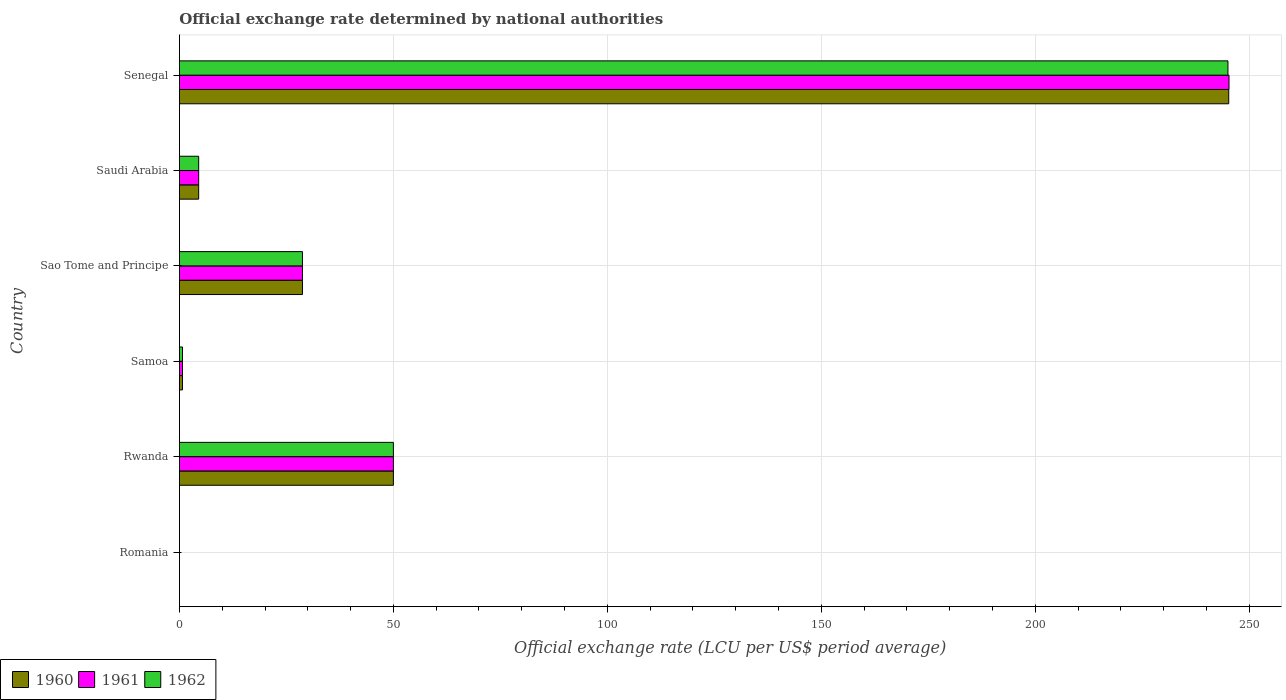How many different coloured bars are there?
Your answer should be compact. 3. Are the number of bars per tick equal to the number of legend labels?
Provide a succinct answer. Yes. Are the number of bars on each tick of the Y-axis equal?
Give a very brief answer. Yes. How many bars are there on the 2nd tick from the top?
Keep it short and to the point. 3. What is the label of the 4th group of bars from the top?
Your answer should be very brief. Samoa. What is the official exchange rate in 1961 in Senegal?
Ensure brevity in your answer.  245.26. Across all countries, what is the maximum official exchange rate in 1962?
Make the answer very short. 245.01. Across all countries, what is the minimum official exchange rate in 1960?
Keep it short and to the point. 0. In which country was the official exchange rate in 1960 maximum?
Provide a short and direct response. Senegal. In which country was the official exchange rate in 1961 minimum?
Ensure brevity in your answer.  Romania. What is the total official exchange rate in 1962 in the graph?
Make the answer very short. 328.98. What is the difference between the official exchange rate in 1962 in Saudi Arabia and that in Senegal?
Give a very brief answer. -240.51. What is the difference between the official exchange rate in 1961 in Rwanda and the official exchange rate in 1960 in Sao Tome and Principe?
Offer a very short reply. 21.25. What is the average official exchange rate in 1960 per country?
Offer a very short reply. 54.86. In how many countries, is the official exchange rate in 1961 greater than 60 LCU?
Give a very brief answer. 1. What is the ratio of the official exchange rate in 1961 in Romania to that in Rwanda?
Make the answer very short. 1.2000000009999998e-5. Is the difference between the official exchange rate in 1960 in Romania and Senegal greater than the difference between the official exchange rate in 1962 in Romania and Senegal?
Keep it short and to the point. No. What is the difference between the highest and the second highest official exchange rate in 1962?
Give a very brief answer. 195.01. What is the difference between the highest and the lowest official exchange rate in 1962?
Ensure brevity in your answer.  245.01. What does the 3rd bar from the bottom in Rwanda represents?
Your answer should be compact. 1962. Is it the case that in every country, the sum of the official exchange rate in 1962 and official exchange rate in 1961 is greater than the official exchange rate in 1960?
Offer a very short reply. Yes. How many bars are there?
Your response must be concise. 18. Are the values on the major ticks of X-axis written in scientific E-notation?
Give a very brief answer. No. How are the legend labels stacked?
Your answer should be compact. Horizontal. What is the title of the graph?
Your answer should be compact. Official exchange rate determined by national authorities. Does "1978" appear as one of the legend labels in the graph?
Your answer should be very brief. No. What is the label or title of the X-axis?
Keep it short and to the point. Official exchange rate (LCU per US$ period average). What is the label or title of the Y-axis?
Provide a succinct answer. Country. What is the Official exchange rate (LCU per US$ period average) in 1960 in Romania?
Give a very brief answer. 0. What is the Official exchange rate (LCU per US$ period average) of 1961 in Romania?
Your answer should be very brief. 0. What is the Official exchange rate (LCU per US$ period average) in 1962 in Romania?
Provide a short and direct response. 0. What is the Official exchange rate (LCU per US$ period average) of 1960 in Rwanda?
Keep it short and to the point. 50. What is the Official exchange rate (LCU per US$ period average) in 1961 in Rwanda?
Keep it short and to the point. 50. What is the Official exchange rate (LCU per US$ period average) of 1962 in Rwanda?
Offer a very short reply. 50. What is the Official exchange rate (LCU per US$ period average) in 1960 in Samoa?
Provide a succinct answer. 0.71. What is the Official exchange rate (LCU per US$ period average) of 1961 in Samoa?
Make the answer very short. 0.72. What is the Official exchange rate (LCU per US$ period average) in 1962 in Samoa?
Offer a very short reply. 0.72. What is the Official exchange rate (LCU per US$ period average) in 1960 in Sao Tome and Principe?
Your answer should be very brief. 28.75. What is the Official exchange rate (LCU per US$ period average) in 1961 in Sao Tome and Principe?
Offer a terse response. 28.75. What is the Official exchange rate (LCU per US$ period average) of 1962 in Sao Tome and Principe?
Provide a short and direct response. 28.75. What is the Official exchange rate (LCU per US$ period average) in 1960 in Saudi Arabia?
Keep it short and to the point. 4.5. What is the Official exchange rate (LCU per US$ period average) of 1961 in Saudi Arabia?
Ensure brevity in your answer.  4.5. What is the Official exchange rate (LCU per US$ period average) in 1962 in Saudi Arabia?
Your answer should be compact. 4.5. What is the Official exchange rate (LCU per US$ period average) of 1960 in Senegal?
Provide a short and direct response. 245.2. What is the Official exchange rate (LCU per US$ period average) in 1961 in Senegal?
Provide a succinct answer. 245.26. What is the Official exchange rate (LCU per US$ period average) of 1962 in Senegal?
Ensure brevity in your answer.  245.01. Across all countries, what is the maximum Official exchange rate (LCU per US$ period average) in 1960?
Provide a short and direct response. 245.2. Across all countries, what is the maximum Official exchange rate (LCU per US$ period average) of 1961?
Give a very brief answer. 245.26. Across all countries, what is the maximum Official exchange rate (LCU per US$ period average) of 1962?
Give a very brief answer. 245.01. Across all countries, what is the minimum Official exchange rate (LCU per US$ period average) of 1960?
Make the answer very short. 0. Across all countries, what is the minimum Official exchange rate (LCU per US$ period average) of 1961?
Keep it short and to the point. 0. Across all countries, what is the minimum Official exchange rate (LCU per US$ period average) in 1962?
Your answer should be compact. 0. What is the total Official exchange rate (LCU per US$ period average) of 1960 in the graph?
Your answer should be compact. 329.16. What is the total Official exchange rate (LCU per US$ period average) of 1961 in the graph?
Provide a short and direct response. 329.23. What is the total Official exchange rate (LCU per US$ period average) of 1962 in the graph?
Keep it short and to the point. 328.98. What is the difference between the Official exchange rate (LCU per US$ period average) of 1960 in Romania and that in Rwanda?
Provide a short and direct response. -50. What is the difference between the Official exchange rate (LCU per US$ period average) in 1961 in Romania and that in Rwanda?
Offer a terse response. -50. What is the difference between the Official exchange rate (LCU per US$ period average) in 1962 in Romania and that in Rwanda?
Your response must be concise. -50. What is the difference between the Official exchange rate (LCU per US$ period average) in 1960 in Romania and that in Samoa?
Keep it short and to the point. -0.71. What is the difference between the Official exchange rate (LCU per US$ period average) in 1961 in Romania and that in Samoa?
Your answer should be compact. -0.71. What is the difference between the Official exchange rate (LCU per US$ period average) in 1962 in Romania and that in Samoa?
Keep it short and to the point. -0.72. What is the difference between the Official exchange rate (LCU per US$ period average) of 1960 in Romania and that in Sao Tome and Principe?
Make the answer very short. -28.75. What is the difference between the Official exchange rate (LCU per US$ period average) of 1961 in Romania and that in Sao Tome and Principe?
Keep it short and to the point. -28.75. What is the difference between the Official exchange rate (LCU per US$ period average) of 1962 in Romania and that in Sao Tome and Principe?
Provide a succinct answer. -28.75. What is the difference between the Official exchange rate (LCU per US$ period average) in 1960 in Romania and that in Saudi Arabia?
Provide a succinct answer. -4.5. What is the difference between the Official exchange rate (LCU per US$ period average) in 1961 in Romania and that in Saudi Arabia?
Keep it short and to the point. -4.5. What is the difference between the Official exchange rate (LCU per US$ period average) in 1962 in Romania and that in Saudi Arabia?
Ensure brevity in your answer.  -4.5. What is the difference between the Official exchange rate (LCU per US$ period average) in 1960 in Romania and that in Senegal?
Make the answer very short. -245.19. What is the difference between the Official exchange rate (LCU per US$ period average) of 1961 in Romania and that in Senegal?
Make the answer very short. -245.26. What is the difference between the Official exchange rate (LCU per US$ period average) of 1962 in Romania and that in Senegal?
Provide a short and direct response. -245.01. What is the difference between the Official exchange rate (LCU per US$ period average) in 1960 in Rwanda and that in Samoa?
Ensure brevity in your answer.  49.29. What is the difference between the Official exchange rate (LCU per US$ period average) in 1961 in Rwanda and that in Samoa?
Provide a short and direct response. 49.28. What is the difference between the Official exchange rate (LCU per US$ period average) of 1962 in Rwanda and that in Samoa?
Your answer should be compact. 49.28. What is the difference between the Official exchange rate (LCU per US$ period average) in 1960 in Rwanda and that in Sao Tome and Principe?
Your answer should be compact. 21.25. What is the difference between the Official exchange rate (LCU per US$ period average) of 1961 in Rwanda and that in Sao Tome and Principe?
Your answer should be compact. 21.25. What is the difference between the Official exchange rate (LCU per US$ period average) of 1962 in Rwanda and that in Sao Tome and Principe?
Ensure brevity in your answer.  21.25. What is the difference between the Official exchange rate (LCU per US$ period average) in 1960 in Rwanda and that in Saudi Arabia?
Offer a very short reply. 45.5. What is the difference between the Official exchange rate (LCU per US$ period average) of 1961 in Rwanda and that in Saudi Arabia?
Your response must be concise. 45.5. What is the difference between the Official exchange rate (LCU per US$ period average) in 1962 in Rwanda and that in Saudi Arabia?
Provide a succinct answer. 45.5. What is the difference between the Official exchange rate (LCU per US$ period average) in 1960 in Rwanda and that in Senegal?
Your response must be concise. -195.2. What is the difference between the Official exchange rate (LCU per US$ period average) of 1961 in Rwanda and that in Senegal?
Offer a very short reply. -195.26. What is the difference between the Official exchange rate (LCU per US$ period average) in 1962 in Rwanda and that in Senegal?
Provide a succinct answer. -195.01. What is the difference between the Official exchange rate (LCU per US$ period average) of 1960 in Samoa and that in Sao Tome and Principe?
Your answer should be compact. -28.04. What is the difference between the Official exchange rate (LCU per US$ period average) in 1961 in Samoa and that in Sao Tome and Principe?
Keep it short and to the point. -28.03. What is the difference between the Official exchange rate (LCU per US$ period average) in 1962 in Samoa and that in Sao Tome and Principe?
Provide a succinct answer. -28.03. What is the difference between the Official exchange rate (LCU per US$ period average) of 1960 in Samoa and that in Saudi Arabia?
Your response must be concise. -3.79. What is the difference between the Official exchange rate (LCU per US$ period average) in 1961 in Samoa and that in Saudi Arabia?
Give a very brief answer. -3.78. What is the difference between the Official exchange rate (LCU per US$ period average) of 1962 in Samoa and that in Saudi Arabia?
Your response must be concise. -3.78. What is the difference between the Official exchange rate (LCU per US$ period average) in 1960 in Samoa and that in Senegal?
Your answer should be compact. -244.48. What is the difference between the Official exchange rate (LCU per US$ period average) of 1961 in Samoa and that in Senegal?
Keep it short and to the point. -244.54. What is the difference between the Official exchange rate (LCU per US$ period average) in 1962 in Samoa and that in Senegal?
Keep it short and to the point. -244.29. What is the difference between the Official exchange rate (LCU per US$ period average) of 1960 in Sao Tome and Principe and that in Saudi Arabia?
Ensure brevity in your answer.  24.25. What is the difference between the Official exchange rate (LCU per US$ period average) in 1961 in Sao Tome and Principe and that in Saudi Arabia?
Make the answer very short. 24.25. What is the difference between the Official exchange rate (LCU per US$ period average) in 1962 in Sao Tome and Principe and that in Saudi Arabia?
Provide a succinct answer. 24.25. What is the difference between the Official exchange rate (LCU per US$ period average) in 1960 in Sao Tome and Principe and that in Senegal?
Your answer should be very brief. -216.45. What is the difference between the Official exchange rate (LCU per US$ period average) in 1961 in Sao Tome and Principe and that in Senegal?
Ensure brevity in your answer.  -216.51. What is the difference between the Official exchange rate (LCU per US$ period average) in 1962 in Sao Tome and Principe and that in Senegal?
Provide a succinct answer. -216.26. What is the difference between the Official exchange rate (LCU per US$ period average) of 1960 in Saudi Arabia and that in Senegal?
Keep it short and to the point. -240.7. What is the difference between the Official exchange rate (LCU per US$ period average) in 1961 in Saudi Arabia and that in Senegal?
Your response must be concise. -240.76. What is the difference between the Official exchange rate (LCU per US$ period average) of 1962 in Saudi Arabia and that in Senegal?
Your response must be concise. -240.51. What is the difference between the Official exchange rate (LCU per US$ period average) in 1960 in Romania and the Official exchange rate (LCU per US$ period average) in 1961 in Rwanda?
Your response must be concise. -50. What is the difference between the Official exchange rate (LCU per US$ period average) in 1960 in Romania and the Official exchange rate (LCU per US$ period average) in 1962 in Rwanda?
Offer a terse response. -50. What is the difference between the Official exchange rate (LCU per US$ period average) of 1961 in Romania and the Official exchange rate (LCU per US$ period average) of 1962 in Rwanda?
Make the answer very short. -50. What is the difference between the Official exchange rate (LCU per US$ period average) of 1960 in Romania and the Official exchange rate (LCU per US$ period average) of 1961 in Samoa?
Offer a terse response. -0.71. What is the difference between the Official exchange rate (LCU per US$ period average) in 1960 in Romania and the Official exchange rate (LCU per US$ period average) in 1962 in Samoa?
Provide a short and direct response. -0.72. What is the difference between the Official exchange rate (LCU per US$ period average) in 1961 in Romania and the Official exchange rate (LCU per US$ period average) in 1962 in Samoa?
Keep it short and to the point. -0.72. What is the difference between the Official exchange rate (LCU per US$ period average) in 1960 in Romania and the Official exchange rate (LCU per US$ period average) in 1961 in Sao Tome and Principe?
Your response must be concise. -28.75. What is the difference between the Official exchange rate (LCU per US$ period average) in 1960 in Romania and the Official exchange rate (LCU per US$ period average) in 1962 in Sao Tome and Principe?
Give a very brief answer. -28.75. What is the difference between the Official exchange rate (LCU per US$ period average) in 1961 in Romania and the Official exchange rate (LCU per US$ period average) in 1962 in Sao Tome and Principe?
Ensure brevity in your answer.  -28.75. What is the difference between the Official exchange rate (LCU per US$ period average) of 1960 in Romania and the Official exchange rate (LCU per US$ period average) of 1961 in Saudi Arabia?
Provide a succinct answer. -4.5. What is the difference between the Official exchange rate (LCU per US$ period average) in 1960 in Romania and the Official exchange rate (LCU per US$ period average) in 1962 in Saudi Arabia?
Make the answer very short. -4.5. What is the difference between the Official exchange rate (LCU per US$ period average) of 1961 in Romania and the Official exchange rate (LCU per US$ period average) of 1962 in Saudi Arabia?
Provide a short and direct response. -4.5. What is the difference between the Official exchange rate (LCU per US$ period average) of 1960 in Romania and the Official exchange rate (LCU per US$ period average) of 1961 in Senegal?
Provide a short and direct response. -245.26. What is the difference between the Official exchange rate (LCU per US$ period average) in 1960 in Romania and the Official exchange rate (LCU per US$ period average) in 1962 in Senegal?
Offer a terse response. -245.01. What is the difference between the Official exchange rate (LCU per US$ period average) in 1961 in Romania and the Official exchange rate (LCU per US$ period average) in 1962 in Senegal?
Offer a very short reply. -245.01. What is the difference between the Official exchange rate (LCU per US$ period average) of 1960 in Rwanda and the Official exchange rate (LCU per US$ period average) of 1961 in Samoa?
Offer a very short reply. 49.28. What is the difference between the Official exchange rate (LCU per US$ period average) of 1960 in Rwanda and the Official exchange rate (LCU per US$ period average) of 1962 in Samoa?
Give a very brief answer. 49.28. What is the difference between the Official exchange rate (LCU per US$ period average) in 1961 in Rwanda and the Official exchange rate (LCU per US$ period average) in 1962 in Samoa?
Offer a terse response. 49.28. What is the difference between the Official exchange rate (LCU per US$ period average) in 1960 in Rwanda and the Official exchange rate (LCU per US$ period average) in 1961 in Sao Tome and Principe?
Provide a succinct answer. 21.25. What is the difference between the Official exchange rate (LCU per US$ period average) of 1960 in Rwanda and the Official exchange rate (LCU per US$ period average) of 1962 in Sao Tome and Principe?
Give a very brief answer. 21.25. What is the difference between the Official exchange rate (LCU per US$ period average) in 1961 in Rwanda and the Official exchange rate (LCU per US$ period average) in 1962 in Sao Tome and Principe?
Offer a very short reply. 21.25. What is the difference between the Official exchange rate (LCU per US$ period average) of 1960 in Rwanda and the Official exchange rate (LCU per US$ period average) of 1961 in Saudi Arabia?
Give a very brief answer. 45.5. What is the difference between the Official exchange rate (LCU per US$ period average) of 1960 in Rwanda and the Official exchange rate (LCU per US$ period average) of 1962 in Saudi Arabia?
Make the answer very short. 45.5. What is the difference between the Official exchange rate (LCU per US$ period average) of 1961 in Rwanda and the Official exchange rate (LCU per US$ period average) of 1962 in Saudi Arabia?
Offer a very short reply. 45.5. What is the difference between the Official exchange rate (LCU per US$ period average) in 1960 in Rwanda and the Official exchange rate (LCU per US$ period average) in 1961 in Senegal?
Keep it short and to the point. -195.26. What is the difference between the Official exchange rate (LCU per US$ period average) of 1960 in Rwanda and the Official exchange rate (LCU per US$ period average) of 1962 in Senegal?
Offer a terse response. -195.01. What is the difference between the Official exchange rate (LCU per US$ period average) of 1961 in Rwanda and the Official exchange rate (LCU per US$ period average) of 1962 in Senegal?
Keep it short and to the point. -195.01. What is the difference between the Official exchange rate (LCU per US$ period average) of 1960 in Samoa and the Official exchange rate (LCU per US$ period average) of 1961 in Sao Tome and Principe?
Provide a short and direct response. -28.04. What is the difference between the Official exchange rate (LCU per US$ period average) in 1960 in Samoa and the Official exchange rate (LCU per US$ period average) in 1962 in Sao Tome and Principe?
Provide a short and direct response. -28.04. What is the difference between the Official exchange rate (LCU per US$ period average) of 1961 in Samoa and the Official exchange rate (LCU per US$ period average) of 1962 in Sao Tome and Principe?
Your answer should be very brief. -28.03. What is the difference between the Official exchange rate (LCU per US$ period average) in 1960 in Samoa and the Official exchange rate (LCU per US$ period average) in 1961 in Saudi Arabia?
Your answer should be compact. -3.79. What is the difference between the Official exchange rate (LCU per US$ period average) of 1960 in Samoa and the Official exchange rate (LCU per US$ period average) of 1962 in Saudi Arabia?
Provide a succinct answer. -3.79. What is the difference between the Official exchange rate (LCU per US$ period average) of 1961 in Samoa and the Official exchange rate (LCU per US$ period average) of 1962 in Saudi Arabia?
Your response must be concise. -3.78. What is the difference between the Official exchange rate (LCU per US$ period average) of 1960 in Samoa and the Official exchange rate (LCU per US$ period average) of 1961 in Senegal?
Your answer should be very brief. -244.55. What is the difference between the Official exchange rate (LCU per US$ period average) in 1960 in Samoa and the Official exchange rate (LCU per US$ period average) in 1962 in Senegal?
Provide a succinct answer. -244.3. What is the difference between the Official exchange rate (LCU per US$ period average) in 1961 in Samoa and the Official exchange rate (LCU per US$ period average) in 1962 in Senegal?
Make the answer very short. -244.3. What is the difference between the Official exchange rate (LCU per US$ period average) of 1960 in Sao Tome and Principe and the Official exchange rate (LCU per US$ period average) of 1961 in Saudi Arabia?
Make the answer very short. 24.25. What is the difference between the Official exchange rate (LCU per US$ period average) of 1960 in Sao Tome and Principe and the Official exchange rate (LCU per US$ period average) of 1962 in Saudi Arabia?
Ensure brevity in your answer.  24.25. What is the difference between the Official exchange rate (LCU per US$ period average) in 1961 in Sao Tome and Principe and the Official exchange rate (LCU per US$ period average) in 1962 in Saudi Arabia?
Your response must be concise. 24.25. What is the difference between the Official exchange rate (LCU per US$ period average) of 1960 in Sao Tome and Principe and the Official exchange rate (LCU per US$ period average) of 1961 in Senegal?
Provide a succinct answer. -216.51. What is the difference between the Official exchange rate (LCU per US$ period average) of 1960 in Sao Tome and Principe and the Official exchange rate (LCU per US$ period average) of 1962 in Senegal?
Keep it short and to the point. -216.26. What is the difference between the Official exchange rate (LCU per US$ period average) in 1961 in Sao Tome and Principe and the Official exchange rate (LCU per US$ period average) in 1962 in Senegal?
Offer a very short reply. -216.26. What is the difference between the Official exchange rate (LCU per US$ period average) in 1960 in Saudi Arabia and the Official exchange rate (LCU per US$ period average) in 1961 in Senegal?
Your response must be concise. -240.76. What is the difference between the Official exchange rate (LCU per US$ period average) in 1960 in Saudi Arabia and the Official exchange rate (LCU per US$ period average) in 1962 in Senegal?
Provide a short and direct response. -240.51. What is the difference between the Official exchange rate (LCU per US$ period average) in 1961 in Saudi Arabia and the Official exchange rate (LCU per US$ period average) in 1962 in Senegal?
Provide a short and direct response. -240.51. What is the average Official exchange rate (LCU per US$ period average) in 1960 per country?
Your answer should be very brief. 54.86. What is the average Official exchange rate (LCU per US$ period average) in 1961 per country?
Offer a terse response. 54.87. What is the average Official exchange rate (LCU per US$ period average) in 1962 per country?
Offer a very short reply. 54.83. What is the difference between the Official exchange rate (LCU per US$ period average) of 1960 and Official exchange rate (LCU per US$ period average) of 1961 in Romania?
Offer a terse response. 0. What is the difference between the Official exchange rate (LCU per US$ period average) in 1960 and Official exchange rate (LCU per US$ period average) in 1962 in Romania?
Make the answer very short. 0. What is the difference between the Official exchange rate (LCU per US$ period average) in 1960 and Official exchange rate (LCU per US$ period average) in 1961 in Rwanda?
Give a very brief answer. 0. What is the difference between the Official exchange rate (LCU per US$ period average) in 1960 and Official exchange rate (LCU per US$ period average) in 1962 in Rwanda?
Make the answer very short. 0. What is the difference between the Official exchange rate (LCU per US$ period average) of 1961 and Official exchange rate (LCU per US$ period average) of 1962 in Rwanda?
Offer a very short reply. 0. What is the difference between the Official exchange rate (LCU per US$ period average) of 1960 and Official exchange rate (LCU per US$ period average) of 1961 in Samoa?
Your response must be concise. -0. What is the difference between the Official exchange rate (LCU per US$ period average) in 1960 and Official exchange rate (LCU per US$ period average) in 1962 in Samoa?
Offer a terse response. -0. What is the difference between the Official exchange rate (LCU per US$ period average) in 1961 and Official exchange rate (LCU per US$ period average) in 1962 in Samoa?
Give a very brief answer. -0. What is the difference between the Official exchange rate (LCU per US$ period average) of 1961 and Official exchange rate (LCU per US$ period average) of 1962 in Sao Tome and Principe?
Ensure brevity in your answer.  0. What is the difference between the Official exchange rate (LCU per US$ period average) of 1960 and Official exchange rate (LCU per US$ period average) of 1961 in Saudi Arabia?
Offer a terse response. 0. What is the difference between the Official exchange rate (LCU per US$ period average) in 1961 and Official exchange rate (LCU per US$ period average) in 1962 in Saudi Arabia?
Keep it short and to the point. 0. What is the difference between the Official exchange rate (LCU per US$ period average) of 1960 and Official exchange rate (LCU per US$ period average) of 1961 in Senegal?
Your response must be concise. -0.07. What is the difference between the Official exchange rate (LCU per US$ period average) of 1960 and Official exchange rate (LCU per US$ period average) of 1962 in Senegal?
Make the answer very short. 0.18. What is the difference between the Official exchange rate (LCU per US$ period average) of 1961 and Official exchange rate (LCU per US$ period average) of 1962 in Senegal?
Your response must be concise. 0.25. What is the ratio of the Official exchange rate (LCU per US$ period average) of 1961 in Romania to that in Rwanda?
Your answer should be very brief. 0. What is the ratio of the Official exchange rate (LCU per US$ period average) of 1960 in Romania to that in Samoa?
Ensure brevity in your answer.  0. What is the ratio of the Official exchange rate (LCU per US$ period average) in 1961 in Romania to that in Samoa?
Your answer should be very brief. 0. What is the ratio of the Official exchange rate (LCU per US$ period average) of 1962 in Romania to that in Samoa?
Provide a short and direct response. 0. What is the ratio of the Official exchange rate (LCU per US$ period average) of 1961 in Romania to that in Sao Tome and Principe?
Offer a terse response. 0. What is the ratio of the Official exchange rate (LCU per US$ period average) of 1962 in Romania to that in Sao Tome and Principe?
Provide a succinct answer. 0. What is the ratio of the Official exchange rate (LCU per US$ period average) of 1961 in Romania to that in Saudi Arabia?
Your answer should be very brief. 0. What is the ratio of the Official exchange rate (LCU per US$ period average) of 1962 in Romania to that in Saudi Arabia?
Keep it short and to the point. 0. What is the ratio of the Official exchange rate (LCU per US$ period average) of 1960 in Romania to that in Senegal?
Make the answer very short. 0. What is the ratio of the Official exchange rate (LCU per US$ period average) in 1960 in Rwanda to that in Samoa?
Ensure brevity in your answer.  70. What is the ratio of the Official exchange rate (LCU per US$ period average) of 1961 in Rwanda to that in Samoa?
Ensure brevity in your answer.  69.88. What is the ratio of the Official exchange rate (LCU per US$ period average) of 1962 in Rwanda to that in Samoa?
Your answer should be compact. 69.52. What is the ratio of the Official exchange rate (LCU per US$ period average) in 1960 in Rwanda to that in Sao Tome and Principe?
Ensure brevity in your answer.  1.74. What is the ratio of the Official exchange rate (LCU per US$ period average) in 1961 in Rwanda to that in Sao Tome and Principe?
Your response must be concise. 1.74. What is the ratio of the Official exchange rate (LCU per US$ period average) of 1962 in Rwanda to that in Sao Tome and Principe?
Your response must be concise. 1.74. What is the ratio of the Official exchange rate (LCU per US$ period average) in 1960 in Rwanda to that in Saudi Arabia?
Your response must be concise. 11.11. What is the ratio of the Official exchange rate (LCU per US$ period average) in 1961 in Rwanda to that in Saudi Arabia?
Offer a terse response. 11.11. What is the ratio of the Official exchange rate (LCU per US$ period average) in 1962 in Rwanda to that in Saudi Arabia?
Make the answer very short. 11.11. What is the ratio of the Official exchange rate (LCU per US$ period average) of 1960 in Rwanda to that in Senegal?
Give a very brief answer. 0.2. What is the ratio of the Official exchange rate (LCU per US$ period average) in 1961 in Rwanda to that in Senegal?
Offer a very short reply. 0.2. What is the ratio of the Official exchange rate (LCU per US$ period average) in 1962 in Rwanda to that in Senegal?
Provide a short and direct response. 0.2. What is the ratio of the Official exchange rate (LCU per US$ period average) of 1960 in Samoa to that in Sao Tome and Principe?
Make the answer very short. 0.02. What is the ratio of the Official exchange rate (LCU per US$ period average) in 1961 in Samoa to that in Sao Tome and Principe?
Ensure brevity in your answer.  0.02. What is the ratio of the Official exchange rate (LCU per US$ period average) in 1962 in Samoa to that in Sao Tome and Principe?
Offer a very short reply. 0.03. What is the ratio of the Official exchange rate (LCU per US$ period average) in 1960 in Samoa to that in Saudi Arabia?
Your response must be concise. 0.16. What is the ratio of the Official exchange rate (LCU per US$ period average) in 1961 in Samoa to that in Saudi Arabia?
Your answer should be very brief. 0.16. What is the ratio of the Official exchange rate (LCU per US$ period average) of 1962 in Samoa to that in Saudi Arabia?
Give a very brief answer. 0.16. What is the ratio of the Official exchange rate (LCU per US$ period average) of 1960 in Samoa to that in Senegal?
Your answer should be compact. 0. What is the ratio of the Official exchange rate (LCU per US$ period average) in 1961 in Samoa to that in Senegal?
Keep it short and to the point. 0. What is the ratio of the Official exchange rate (LCU per US$ period average) in 1962 in Samoa to that in Senegal?
Give a very brief answer. 0. What is the ratio of the Official exchange rate (LCU per US$ period average) of 1960 in Sao Tome and Principe to that in Saudi Arabia?
Make the answer very short. 6.39. What is the ratio of the Official exchange rate (LCU per US$ period average) in 1961 in Sao Tome and Principe to that in Saudi Arabia?
Make the answer very short. 6.39. What is the ratio of the Official exchange rate (LCU per US$ period average) in 1962 in Sao Tome and Principe to that in Saudi Arabia?
Offer a very short reply. 6.39. What is the ratio of the Official exchange rate (LCU per US$ period average) in 1960 in Sao Tome and Principe to that in Senegal?
Give a very brief answer. 0.12. What is the ratio of the Official exchange rate (LCU per US$ period average) in 1961 in Sao Tome and Principe to that in Senegal?
Offer a terse response. 0.12. What is the ratio of the Official exchange rate (LCU per US$ period average) in 1962 in Sao Tome and Principe to that in Senegal?
Offer a very short reply. 0.12. What is the ratio of the Official exchange rate (LCU per US$ period average) in 1960 in Saudi Arabia to that in Senegal?
Make the answer very short. 0.02. What is the ratio of the Official exchange rate (LCU per US$ period average) of 1961 in Saudi Arabia to that in Senegal?
Your answer should be very brief. 0.02. What is the ratio of the Official exchange rate (LCU per US$ period average) of 1962 in Saudi Arabia to that in Senegal?
Give a very brief answer. 0.02. What is the difference between the highest and the second highest Official exchange rate (LCU per US$ period average) of 1960?
Ensure brevity in your answer.  195.2. What is the difference between the highest and the second highest Official exchange rate (LCU per US$ period average) of 1961?
Ensure brevity in your answer.  195.26. What is the difference between the highest and the second highest Official exchange rate (LCU per US$ period average) in 1962?
Offer a very short reply. 195.01. What is the difference between the highest and the lowest Official exchange rate (LCU per US$ period average) of 1960?
Offer a very short reply. 245.19. What is the difference between the highest and the lowest Official exchange rate (LCU per US$ period average) of 1961?
Ensure brevity in your answer.  245.26. What is the difference between the highest and the lowest Official exchange rate (LCU per US$ period average) of 1962?
Give a very brief answer. 245.01. 